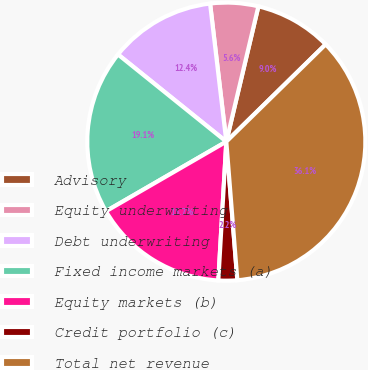Convert chart to OTSL. <chart><loc_0><loc_0><loc_500><loc_500><pie_chart><fcel>Advisory<fcel>Equity underwriting<fcel>Debt underwriting<fcel>Fixed income markets (a)<fcel>Equity markets (b)<fcel>Credit portfolio (c)<fcel>Total net revenue<nl><fcel>8.96%<fcel>5.57%<fcel>12.35%<fcel>19.13%<fcel>15.74%<fcel>2.18%<fcel>36.07%<nl></chart> 